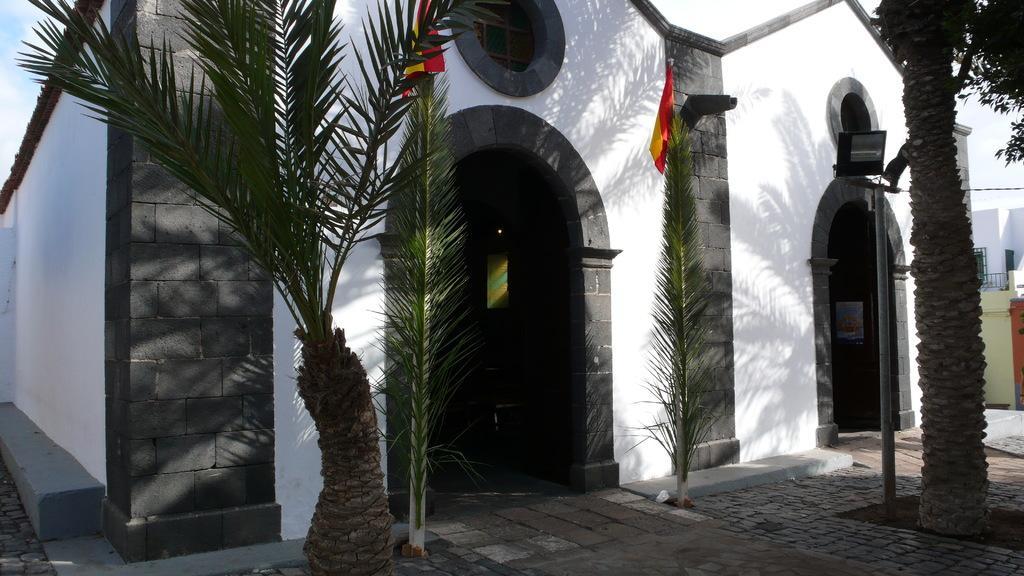Describe this image in one or two sentences. In the image there is a building with palm trees on either side of it and a flag in the middle and above its sky. 